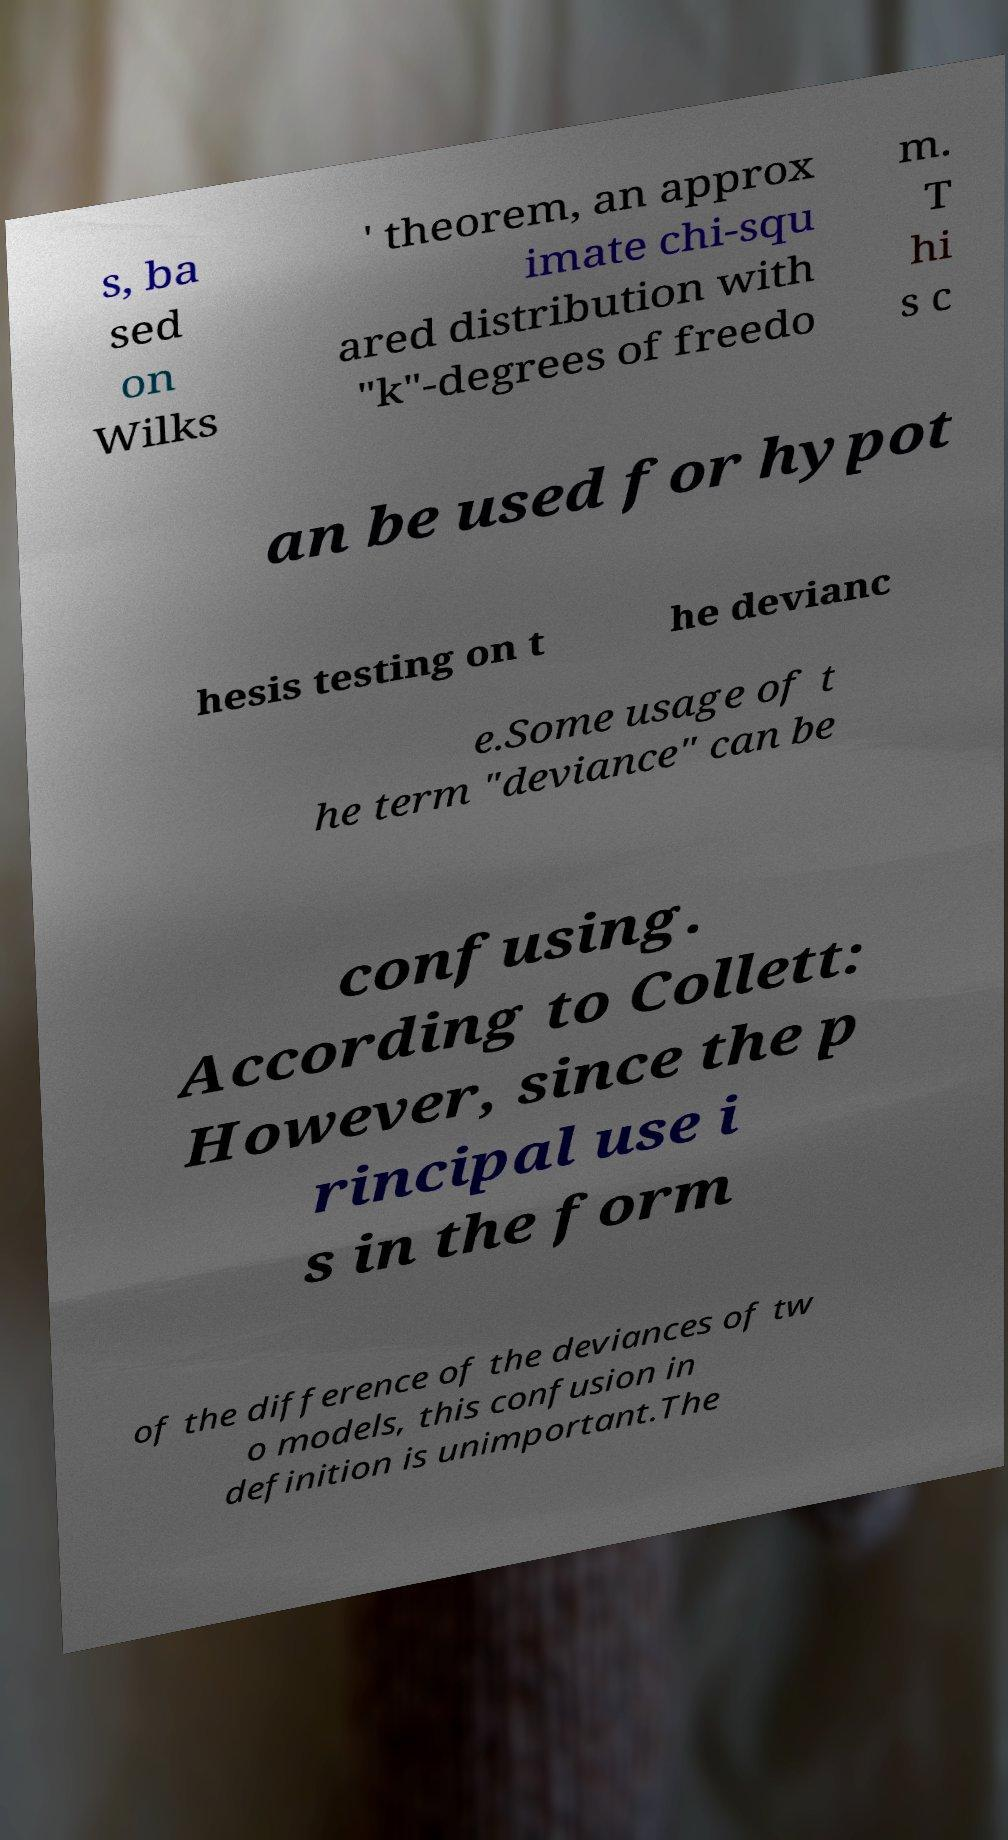Could you assist in decoding the text presented in this image and type it out clearly? s, ba sed on Wilks ' theorem, an approx imate chi-squ ared distribution with "k"-degrees of freedo m. T hi s c an be used for hypot hesis testing on t he devianc e.Some usage of t he term "deviance" can be confusing. According to Collett: However, since the p rincipal use i s in the form of the difference of the deviances of tw o models, this confusion in definition is unimportant.The 